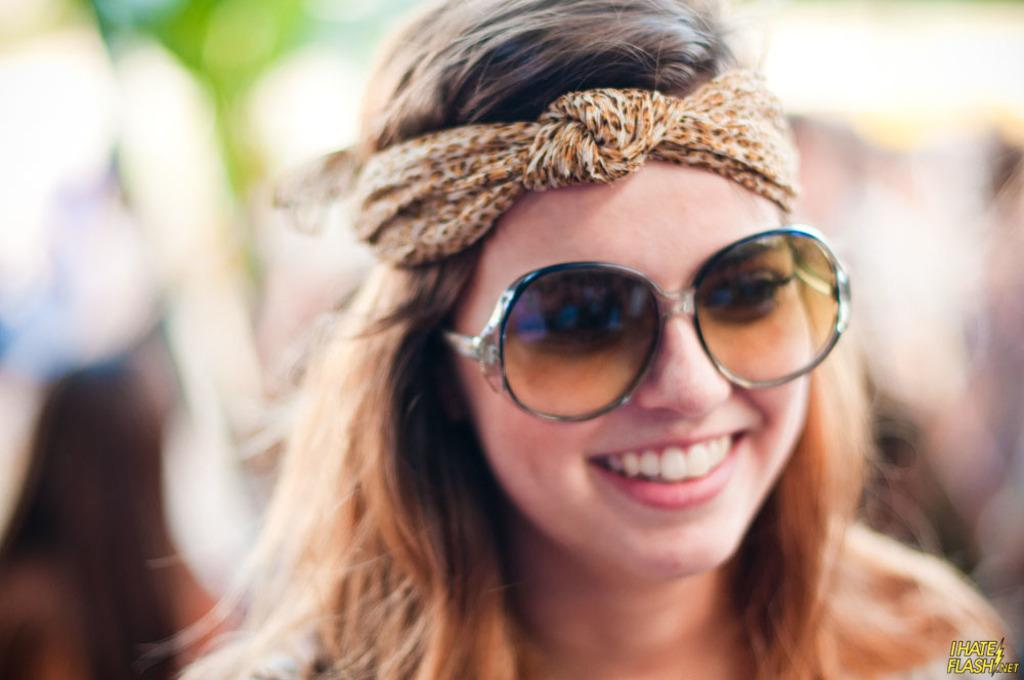Who is the main subject in the image? There is a woman in the middle of the image. What is the woman doing in the image? The woman is smiling. Can you describe the background of the image? The background is blurry. Is there any text visible in the image? Yes, there is some text in the bottom right-hand corner of the image. What type of flesh can be seen on the woman's face in the image? There is no flesh visible on the woman's face in the image; it is a photograph, not a medical illustration. 